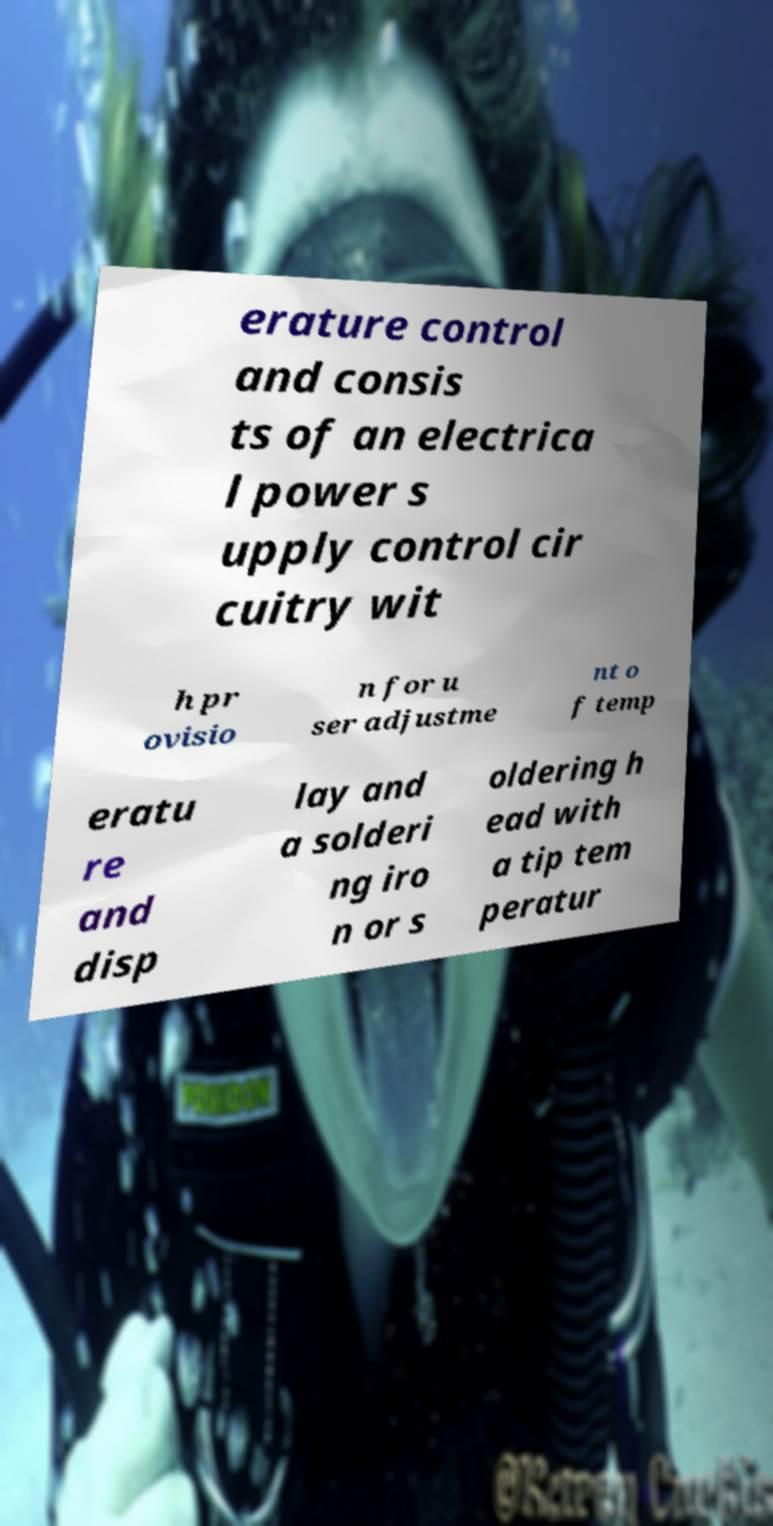Can you accurately transcribe the text from the provided image for me? erature control and consis ts of an electrica l power s upply control cir cuitry wit h pr ovisio n for u ser adjustme nt o f temp eratu re and disp lay and a solderi ng iro n or s oldering h ead with a tip tem peratur 